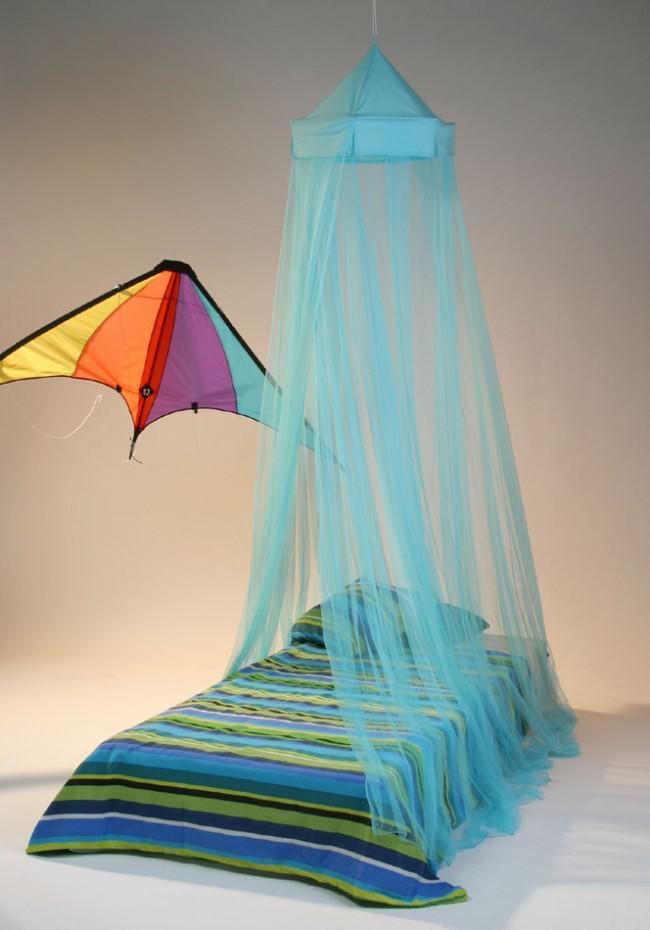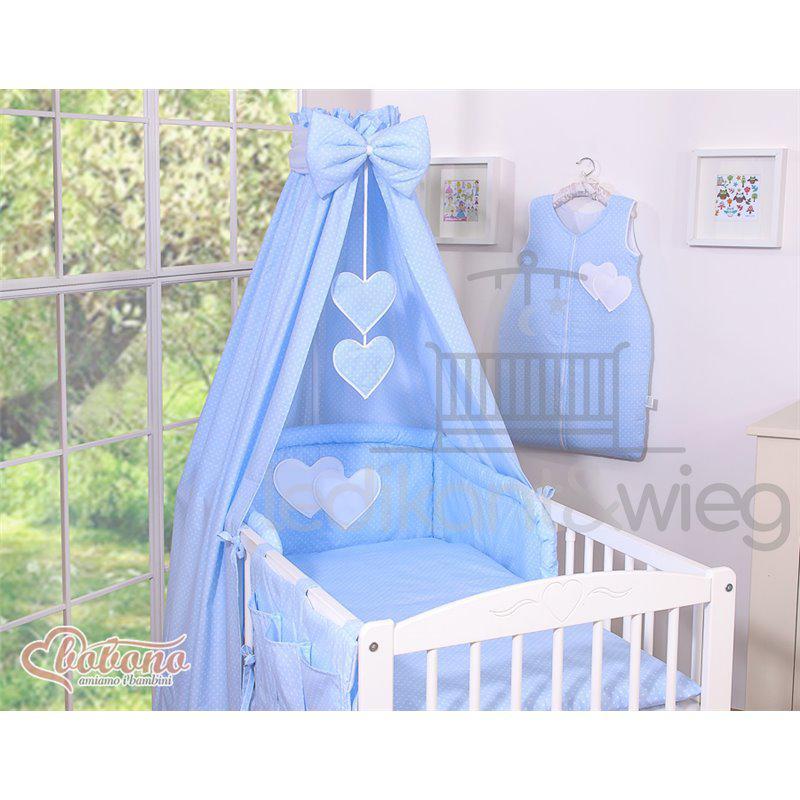The first image is the image on the left, the second image is the image on the right. Considering the images on both sides, is "An image shows a suspended blue canopy that does not cover the foot of a bed with a bold print bedspread." valid? Answer yes or no. Yes. 